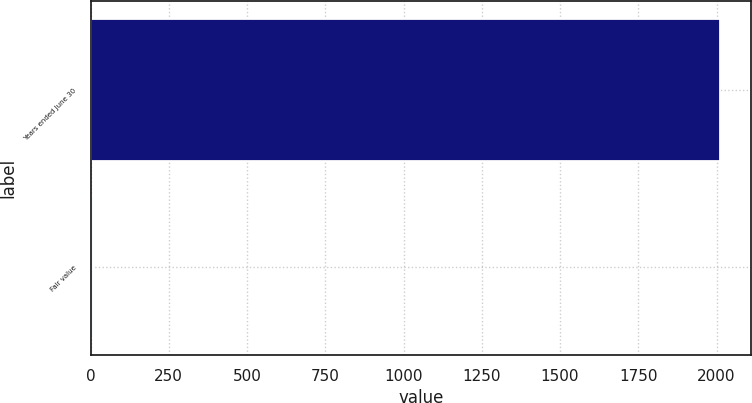Convert chart to OTSL. <chart><loc_0><loc_0><loc_500><loc_500><bar_chart><fcel>Years ended June 30<fcel>Fair value<nl><fcel>2010<fcel>7.05<nl></chart> 